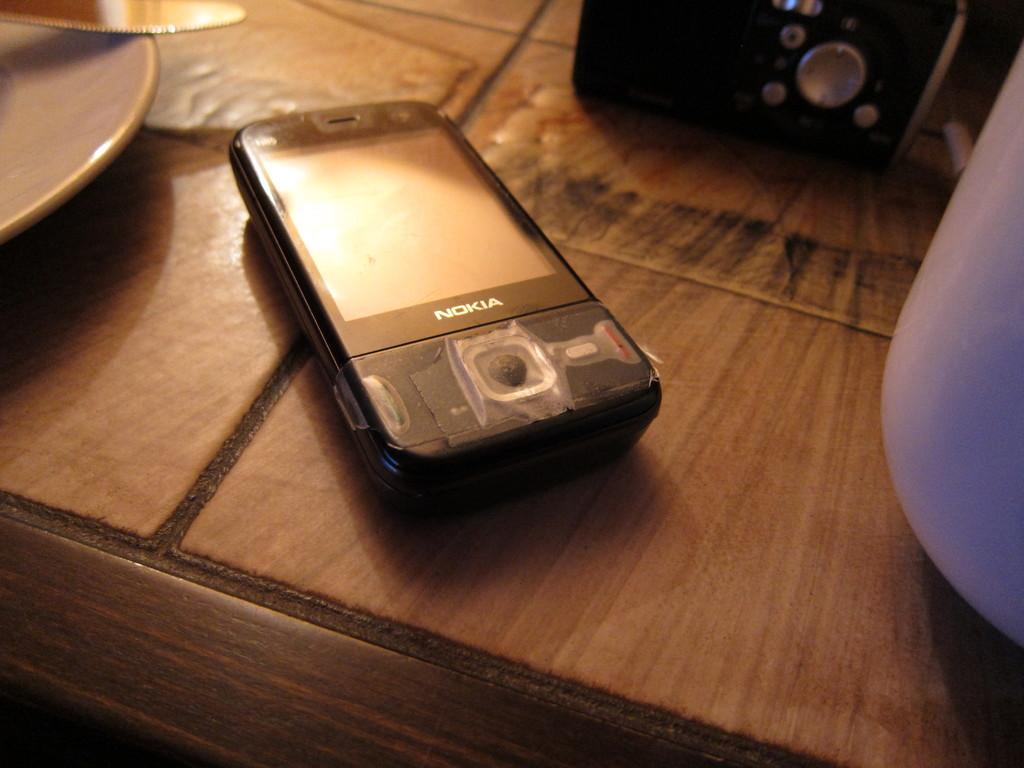What object is located on the table in the image? There is a mobile on the table. What other object can be seen on the table? There is a remote on the table. What else is present on the table? There is a plate and a cup on the table. What type of car is parked in front of the table in the image? There is no car present in the image; it only shows objects on a table. 